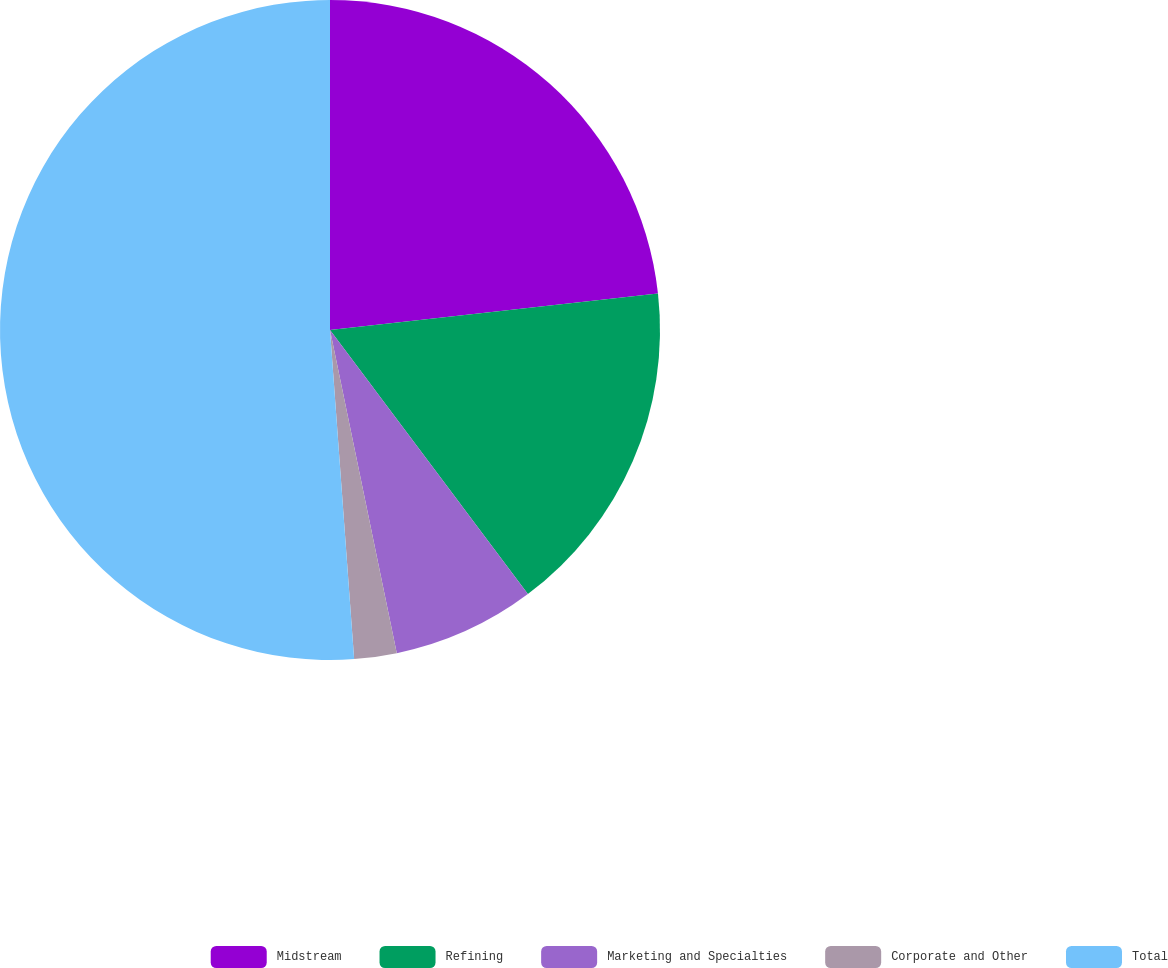Convert chart. <chart><loc_0><loc_0><loc_500><loc_500><pie_chart><fcel>Midstream<fcel>Refining<fcel>Marketing and Specialties<fcel>Corporate and Other<fcel>Total<nl><fcel>23.24%<fcel>16.53%<fcel>6.99%<fcel>2.08%<fcel>51.17%<nl></chart> 